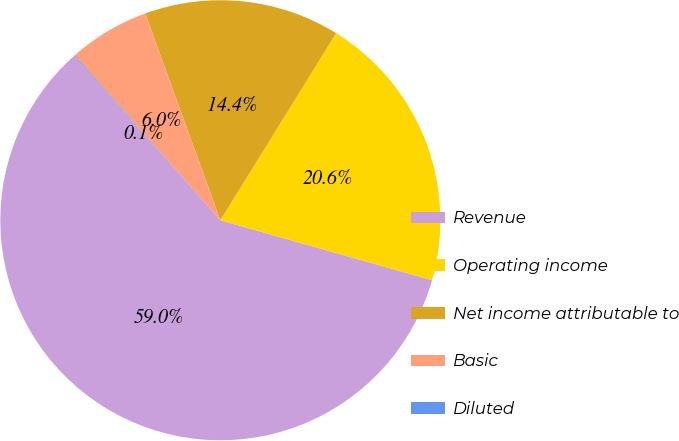Convert chart. <chart><loc_0><loc_0><loc_500><loc_500><pie_chart><fcel>Revenue<fcel>Operating income<fcel>Net income attributable to<fcel>Basic<fcel>Diluted<nl><fcel>59.04%<fcel>20.57%<fcel>14.37%<fcel>5.96%<fcel>0.06%<nl></chart> 